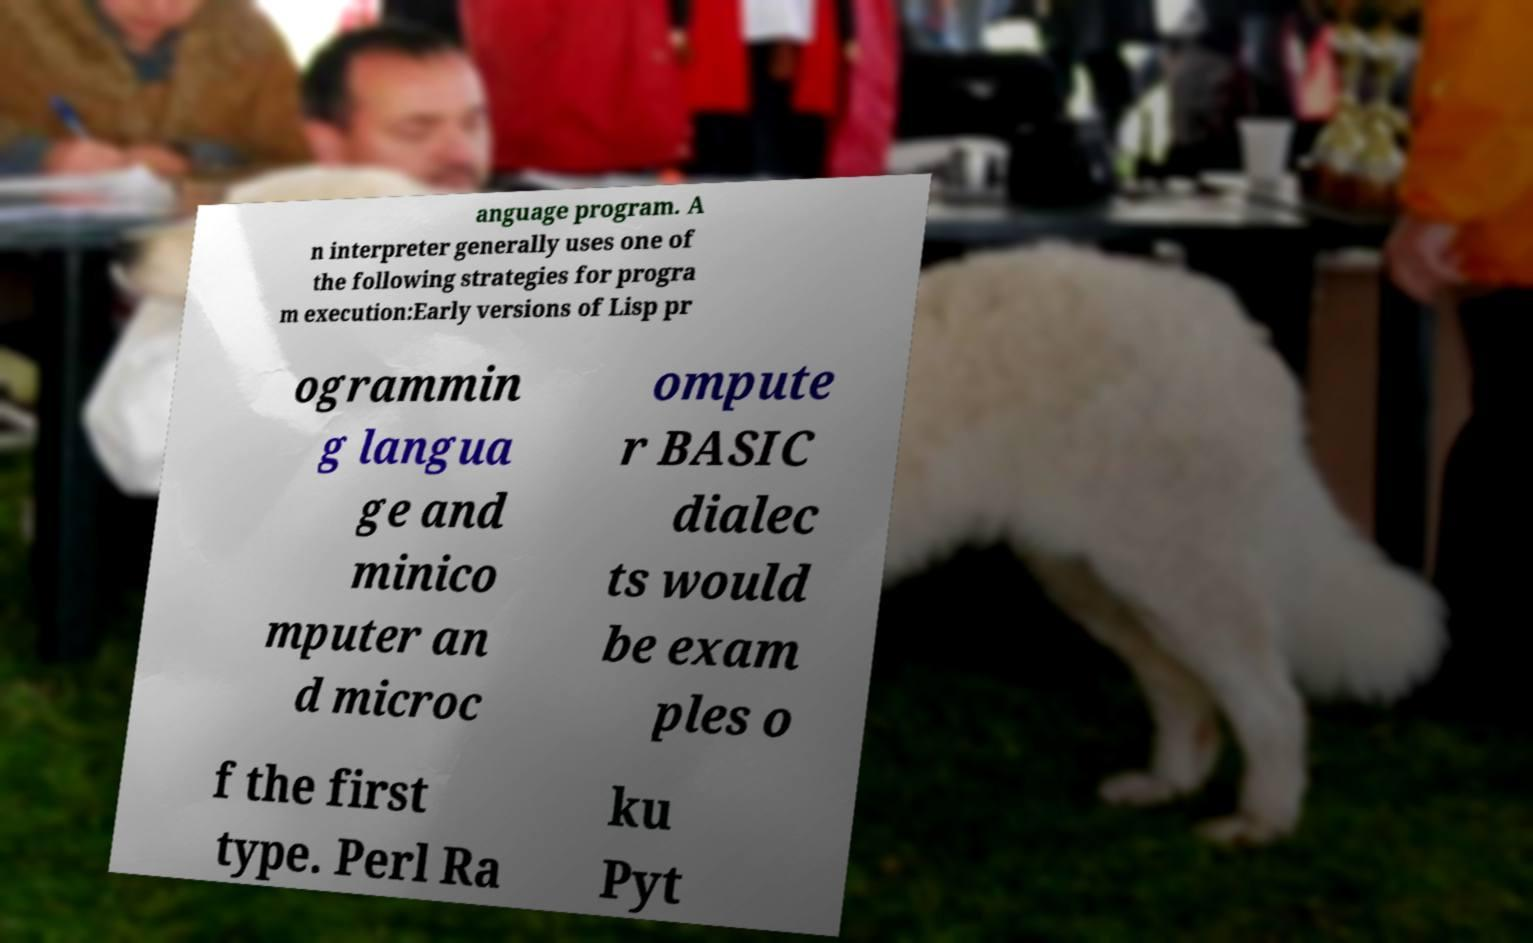Please identify and transcribe the text found in this image. anguage program. A n interpreter generally uses one of the following strategies for progra m execution:Early versions of Lisp pr ogrammin g langua ge and minico mputer an d microc ompute r BASIC dialec ts would be exam ples o f the first type. Perl Ra ku Pyt 